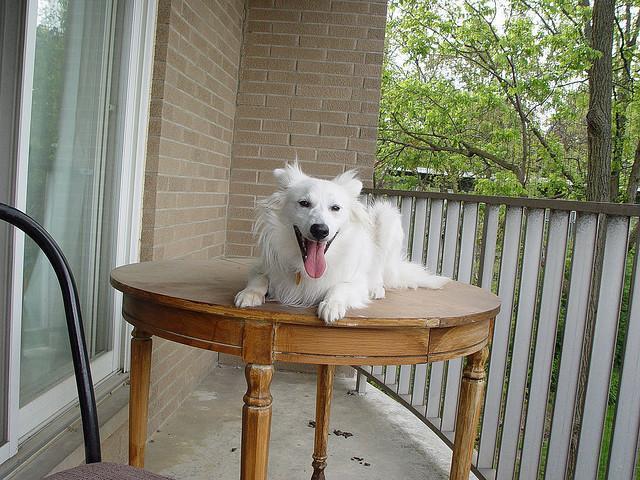How many dining tables can be seen?
Give a very brief answer. 1. 